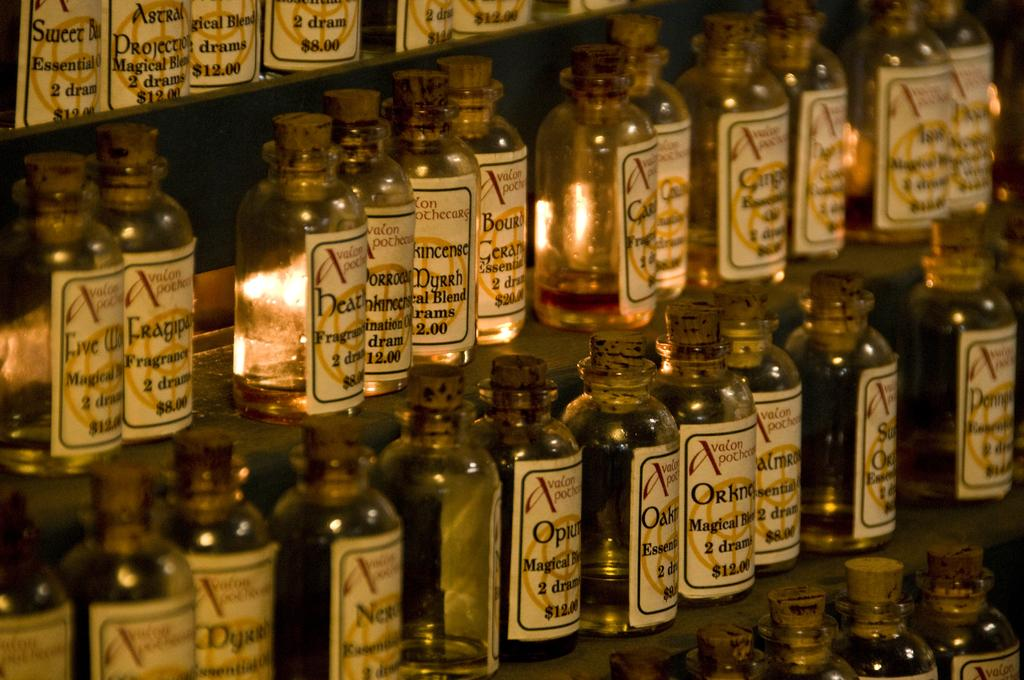<image>
Give a short and clear explanation of the subsequent image. A display of essential oils sits on a shelf with one costing $12.00 